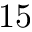Convert formula to latex. <formula><loc_0><loc_0><loc_500><loc_500>1 5</formula> 